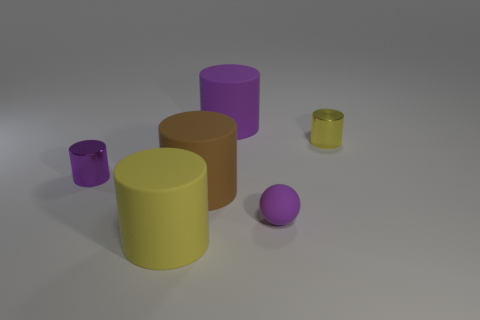What number of brown objects are the same size as the yellow metal object?
Your answer should be compact. 0. Is the number of purple cylinders less than the number of tiny purple rubber things?
Keep it short and to the point. No. What shape is the tiny purple shiny thing to the left of the cylinder that is to the right of the tiny rubber object?
Your response must be concise. Cylinder. What shape is the purple metallic object that is the same size as the purple ball?
Offer a terse response. Cylinder. Are there any large yellow objects of the same shape as the big brown thing?
Your answer should be compact. Yes. What material is the small purple cylinder?
Offer a very short reply. Metal. Are there any large purple things right of the tiny purple matte object?
Give a very brief answer. No. How many small shiny cylinders are on the right side of the big object that is behind the small yellow metal thing?
Your answer should be very brief. 1. What is the material of the yellow object that is the same size as the purple matte ball?
Your answer should be compact. Metal. How many other things are there of the same material as the small yellow cylinder?
Offer a terse response. 1. 